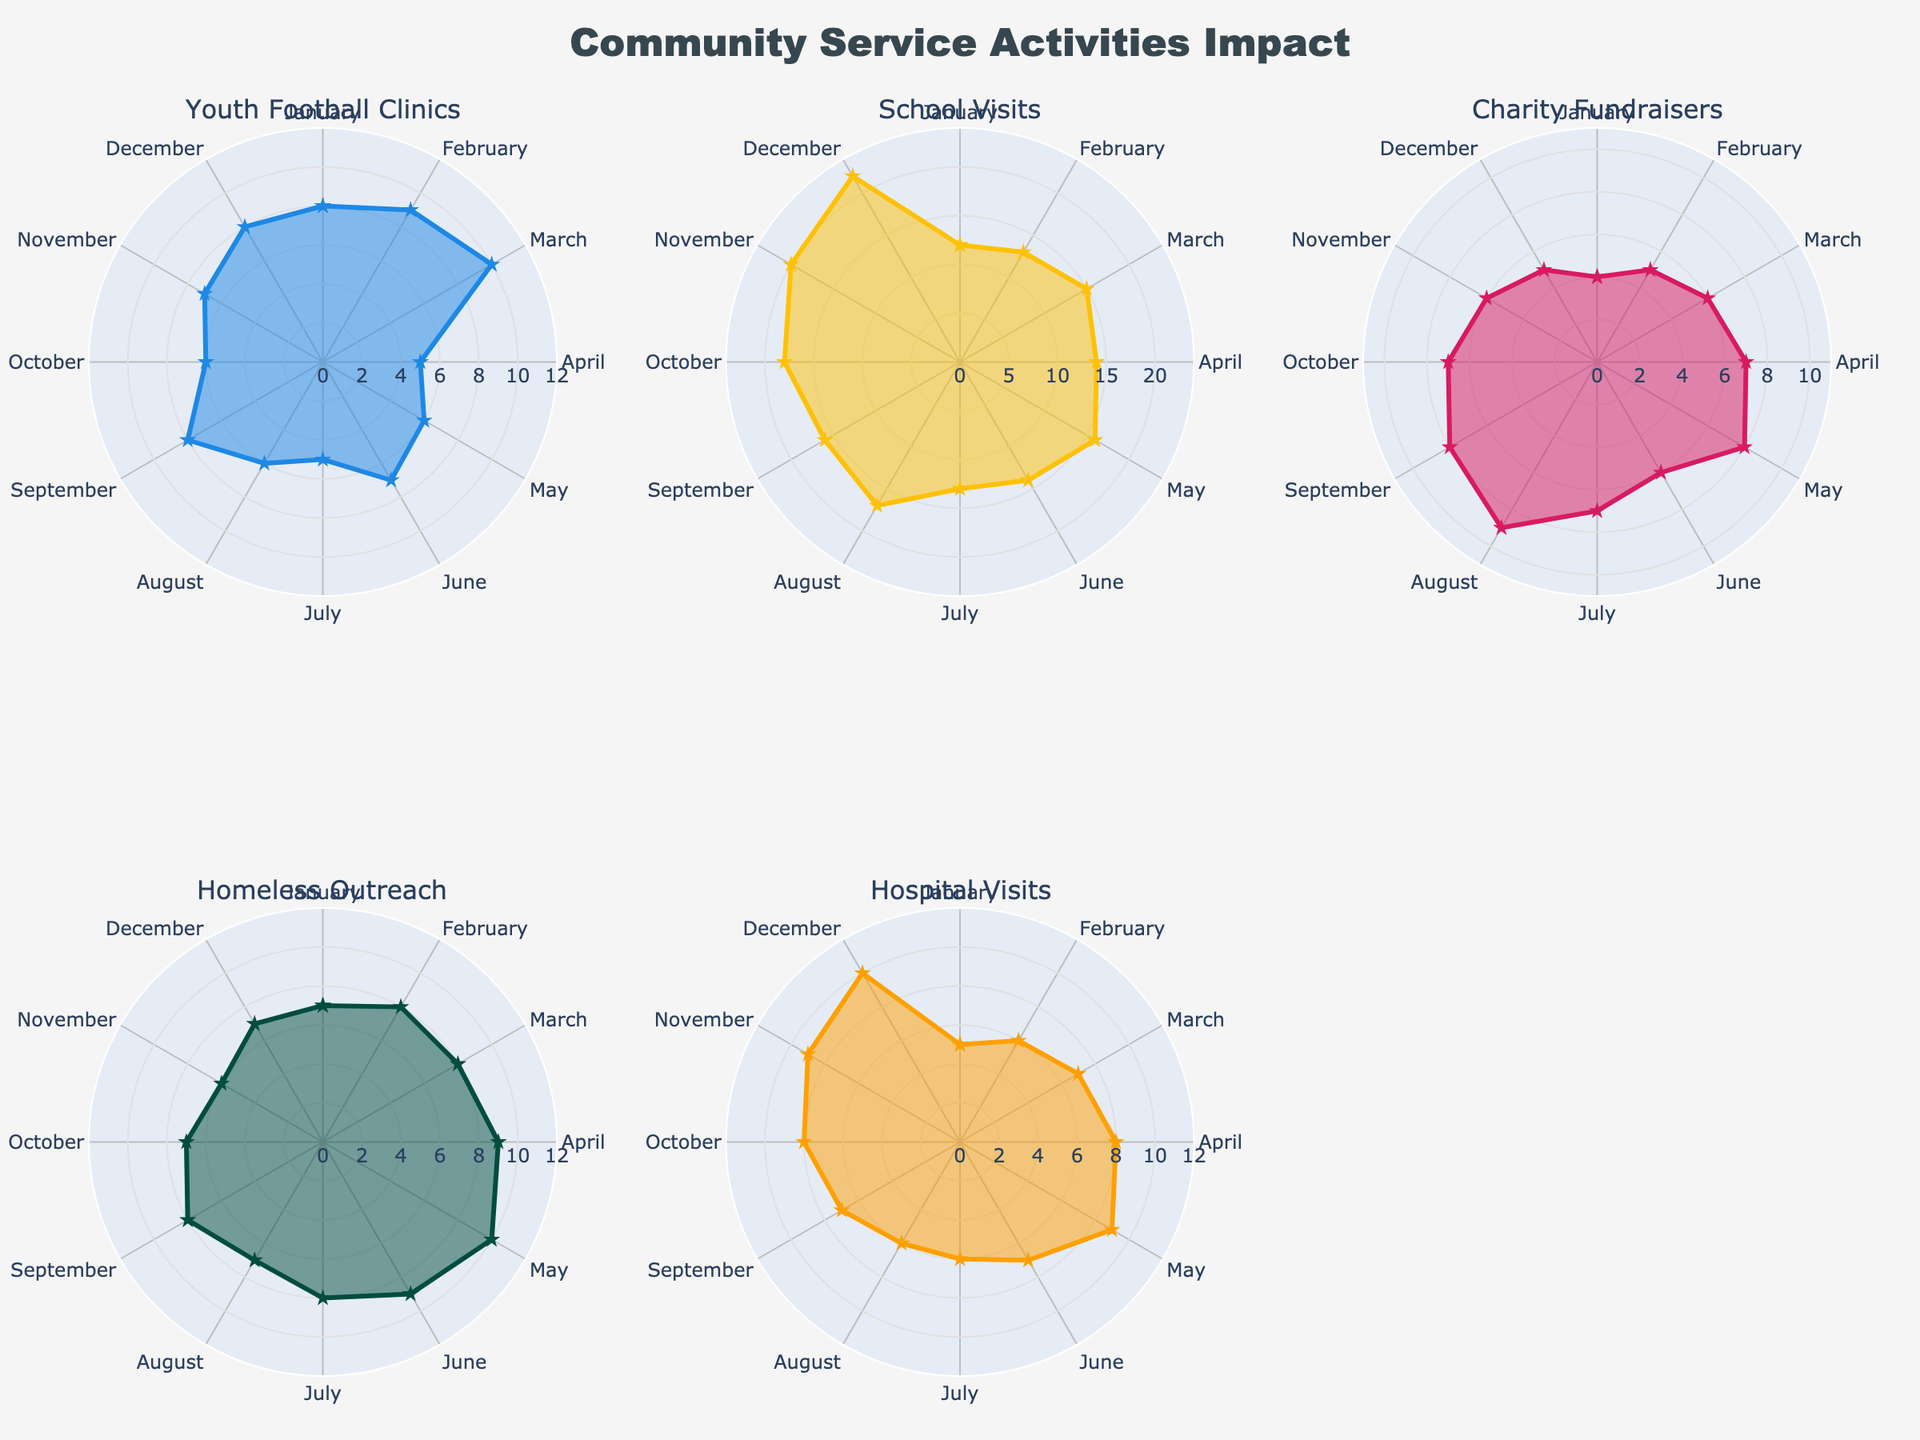What is the title of the figure? The title is usually located at the top center of the figure. In this case, the title displayed is "Community Service Activities Impact".
Answer: Community Service Activities Impact What event had the highest impact in February? By reviewing the figure and comparing the radial length of each event in February, the "School Visits" subplot shows the highest value.
Answer: School Visits Which event showed the lowest impact in July? To find this, compare the values for each event in July. The shortest radial length in July is for "Youth Football Clinics".
Answer: Youth Football Clinics Is there any event whose impact consistently increased from January to December? By examining the trends in each subplot, "Hospital Visits" shows a steady increase in impact from January to December.
Answer: Hospital Visits What is the combined impact of "School Visits" and "Charity Fundraisers" in September? First, find the impact values for both events in September: School Visits (16) and Charity Fundraisers (8). Adding these values gives 16 + 8 = 24.
Answer: 24 Which event shows the most variability in its impact over the months? To determine this, observe the fluctuation magnitudes in each subplot. "School Visits" varies the most, ranging from 12 to 22.
Answer: School Visits During which month is the impact of "Homeless Outreach" and "Hospital Visits" equal? By comparing the values for each month, both "Homeless Outreach" and "Hospital Visits" have the same impact (7) in July.
Answer: July How many events showed an increasing trend from January to May? Check each subplot for increases from January to May. "School Visits", "Charity Fundraisers", and "Hospital Visits" show increasing trends. So, there are three events.
Answer: Three events Which event saw the greatest drop in impact from one month to the next? Locate the steepest decline in impact. "School Visits" drops the most significantly from February (13) to April (14), a decrease from 16 to 14.
Answer: School Visits 